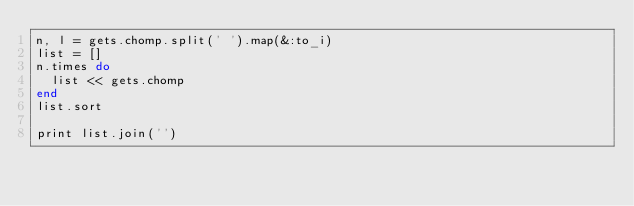<code> <loc_0><loc_0><loc_500><loc_500><_Ruby_>n, l = gets.chomp.split(' ').map(&:to_i)
list = []
n.times do
  list << gets.chomp
end
list.sort

print list.join('')</code> 